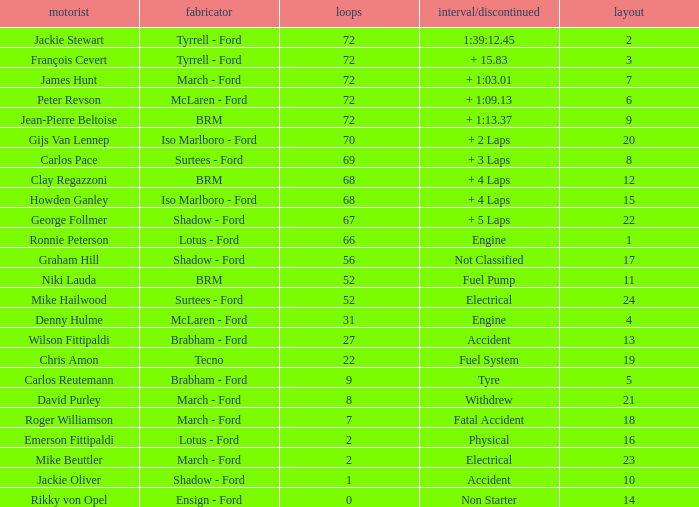What is the top grid that laps less than 66 and a retried engine? 4.0. 